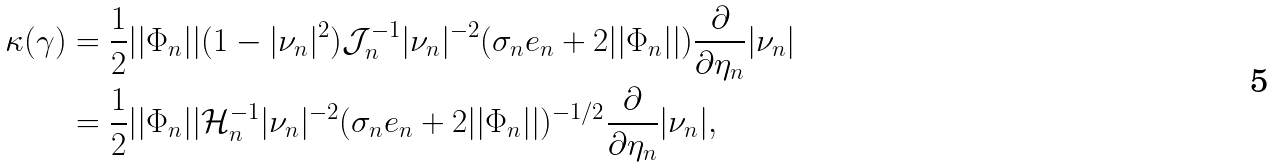<formula> <loc_0><loc_0><loc_500><loc_500>\kappa ( \gamma ) & = \frac { 1 } { 2 } | | \Phi _ { n } | | ( 1 - | \nu _ { n } | ^ { 2 } ) \mathcal { J } _ { n } ^ { - 1 } | \nu _ { n } | ^ { - 2 } ( \sigma _ { n } e _ { n } + 2 | | \Phi _ { n } | | ) \frac { \partial } { \partial \eta _ { n } } | \nu _ { n } | \\ & = \frac { 1 } { 2 } | | \Phi _ { n } | | \mathcal { H } _ { n } ^ { - 1 } | \nu _ { n } | ^ { - 2 } ( \sigma _ { n } e _ { n } + 2 | | \Phi _ { n } | | ) ^ { - 1 / 2 } \frac { \partial } { \partial \eta _ { n } } | \nu _ { n } | ,</formula> 